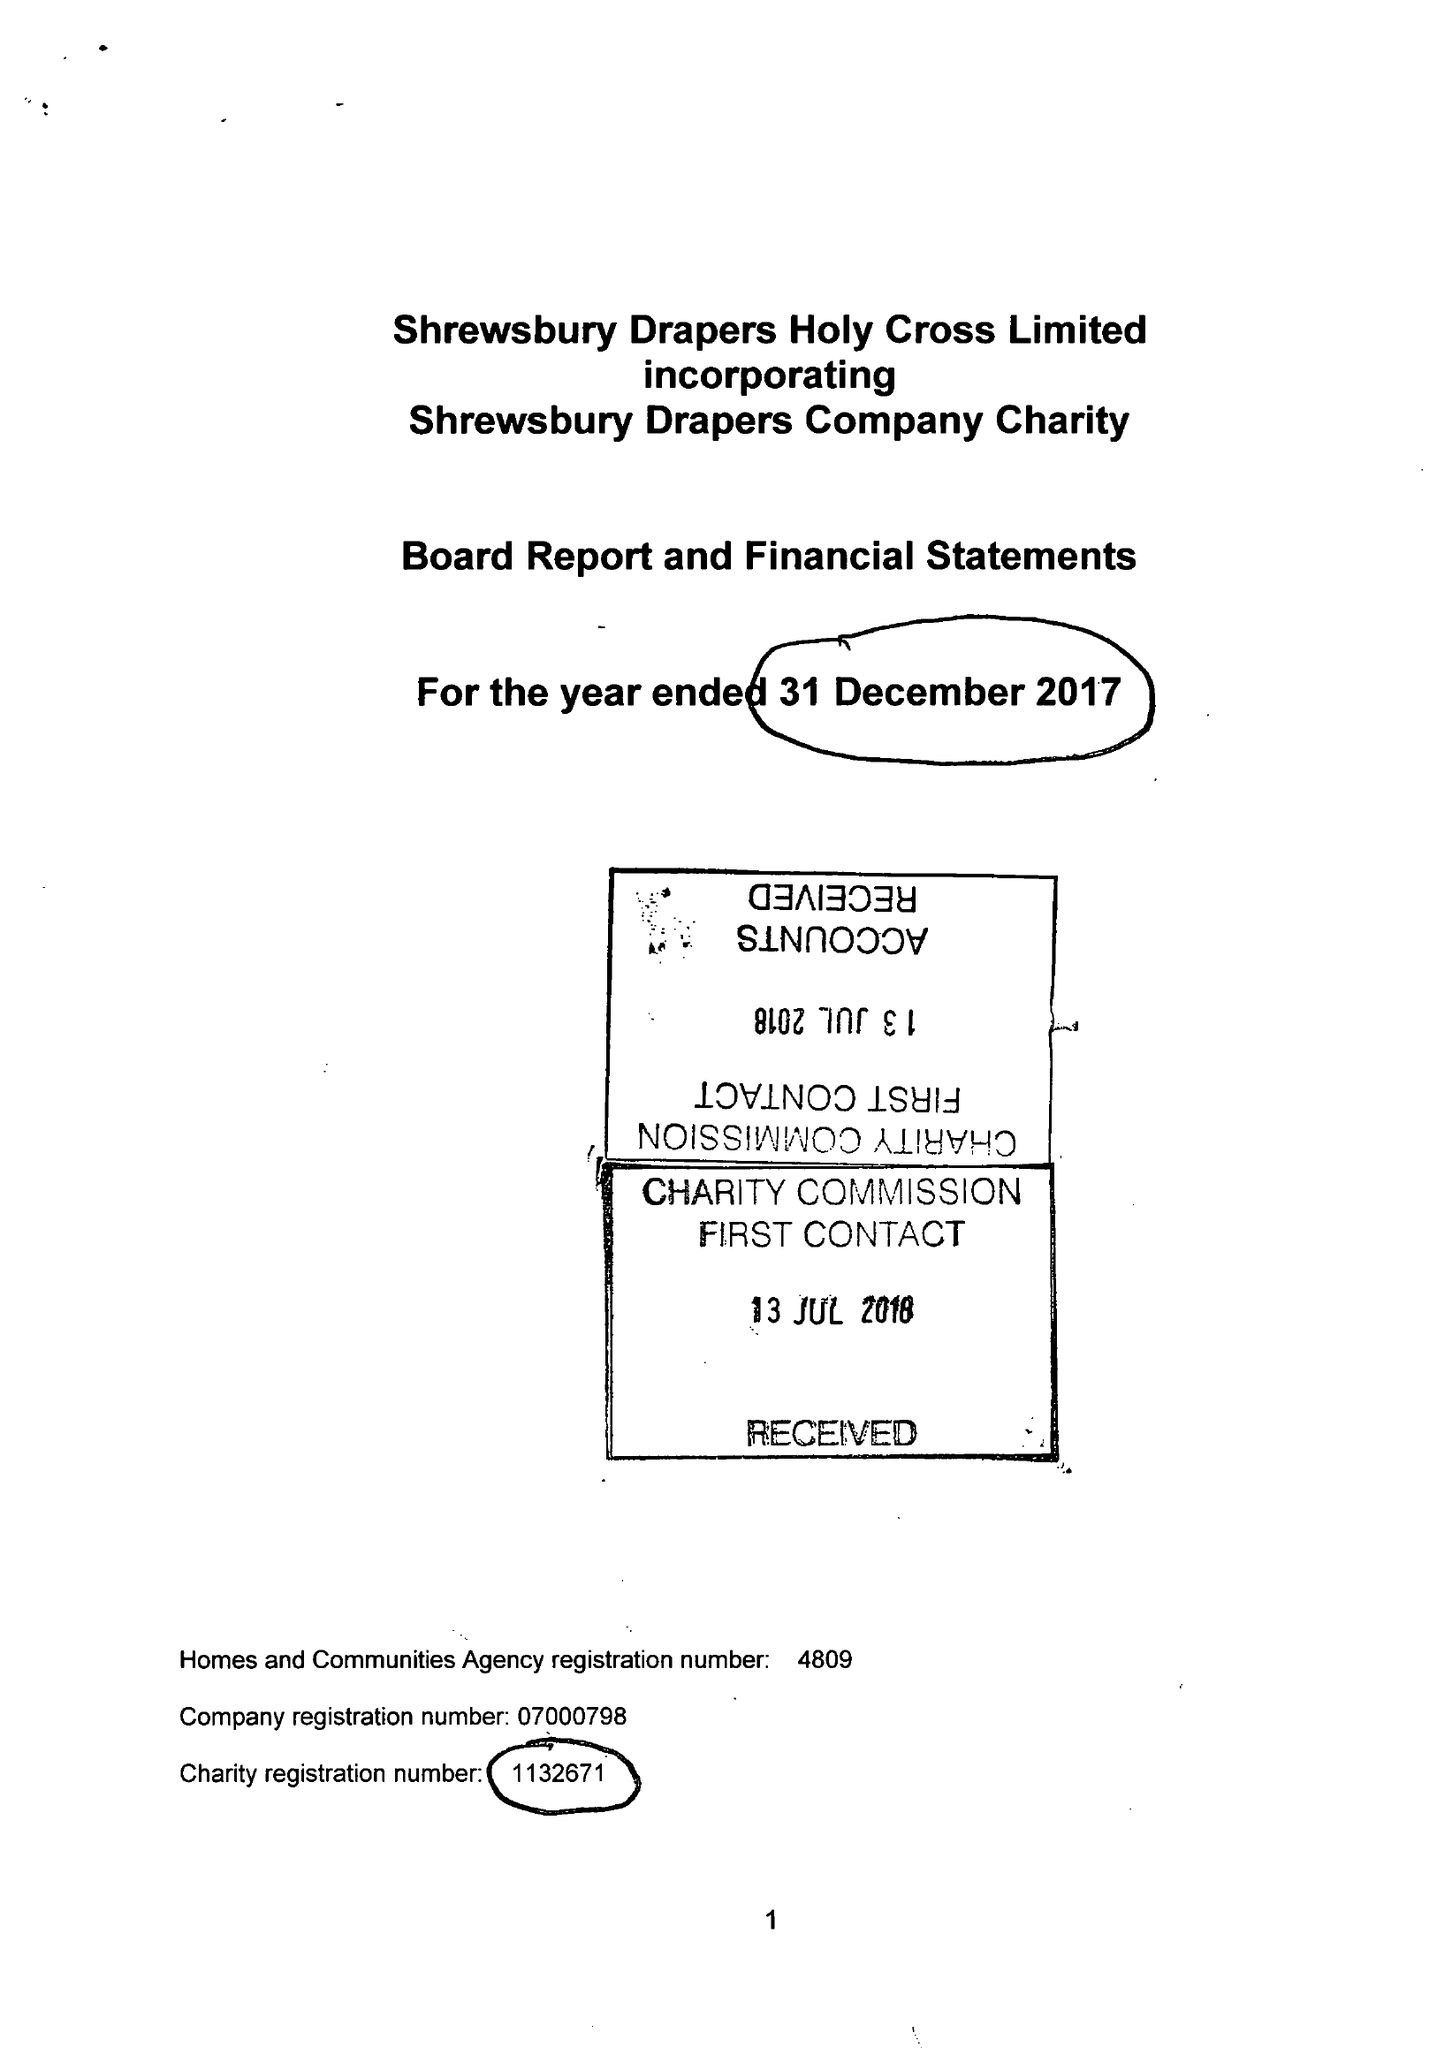What is the value for the address__street_line?
Answer the question using a single word or phrase. None 